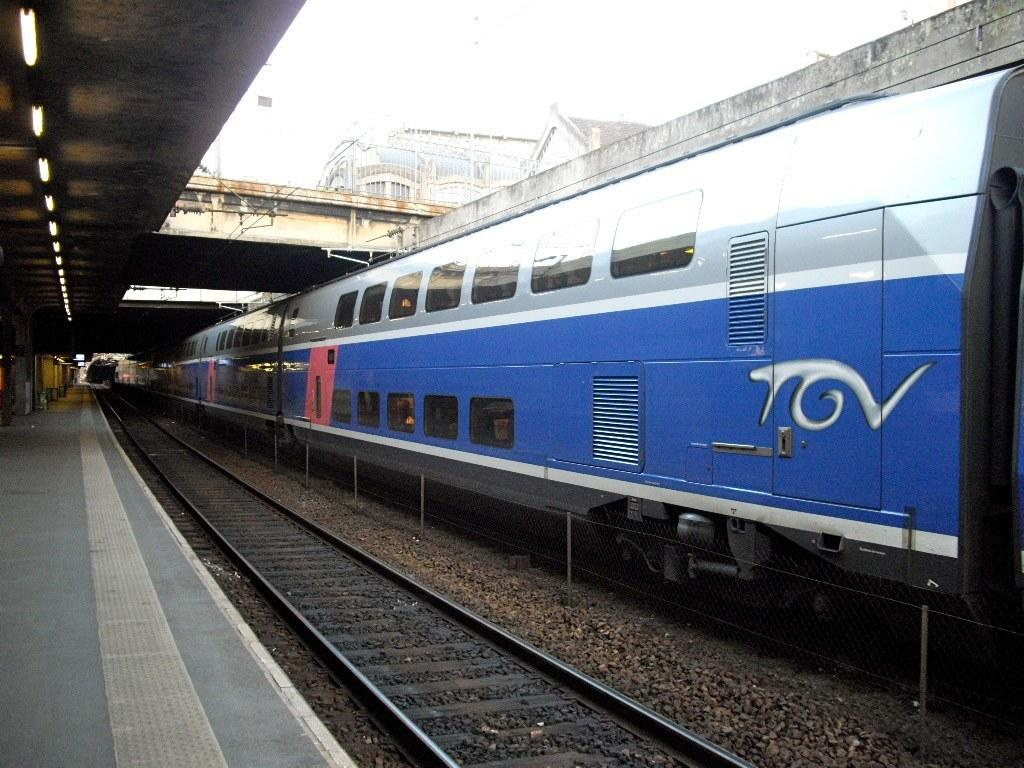What is the main subject of the image? The main subject of the image is a train. Where is the train located in the image? The train is on a train track. What other structures can be seen in the image? There is a bridge in the image. What feature is present on the roof of the train? There are lights on the roof of the train. How many beds can be seen in the image? There are no beds present in the image; it features a train on a train track with a bridge in the background. Are there any apples visible on the train? There are no apples visible on the train or in the image. 